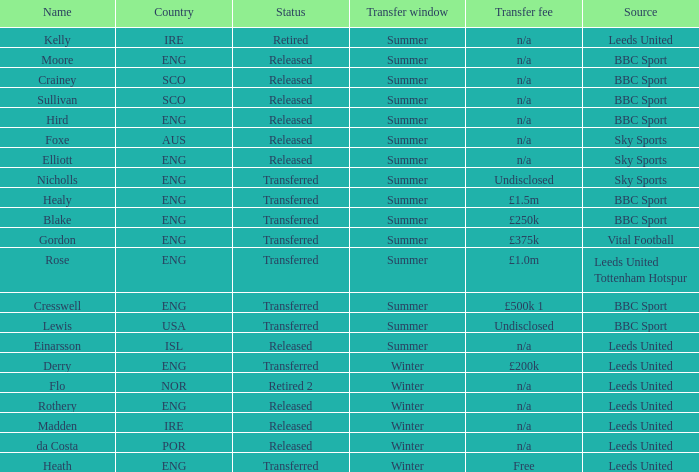What was the basis for the existence of someone named cresswell? BBC Sport. 